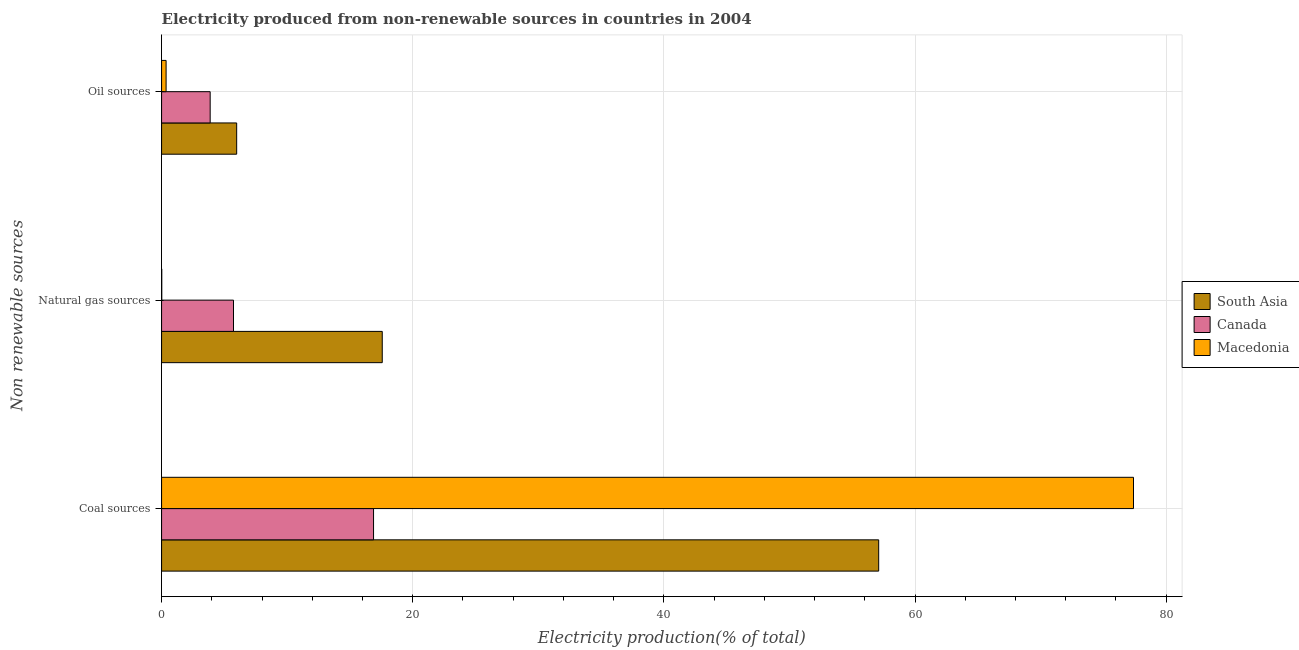How many groups of bars are there?
Offer a terse response. 3. Are the number of bars on each tick of the Y-axis equal?
Keep it short and to the point. Yes. What is the label of the 2nd group of bars from the top?
Offer a terse response. Natural gas sources. What is the percentage of electricity produced by oil sources in Canada?
Your answer should be very brief. 3.87. Across all countries, what is the maximum percentage of electricity produced by natural gas?
Your answer should be very brief. 17.57. Across all countries, what is the minimum percentage of electricity produced by natural gas?
Make the answer very short. 0.01. In which country was the percentage of electricity produced by coal maximum?
Offer a very short reply. Macedonia. In which country was the percentage of electricity produced by oil sources minimum?
Make the answer very short. Macedonia. What is the total percentage of electricity produced by oil sources in the graph?
Provide a short and direct response. 10.21. What is the difference between the percentage of electricity produced by natural gas in Canada and that in Macedonia?
Your answer should be very brief. 5.71. What is the difference between the percentage of electricity produced by coal in South Asia and the percentage of electricity produced by natural gas in Canada?
Provide a succinct answer. 51.38. What is the average percentage of electricity produced by oil sources per country?
Your answer should be very brief. 3.4. What is the difference between the percentage of electricity produced by oil sources and percentage of electricity produced by natural gas in South Asia?
Keep it short and to the point. -11.59. In how many countries, is the percentage of electricity produced by oil sources greater than 12 %?
Your answer should be very brief. 0. What is the ratio of the percentage of electricity produced by natural gas in Canada to that in Macedonia?
Offer a terse response. 381.86. What is the difference between the highest and the second highest percentage of electricity produced by oil sources?
Your answer should be compact. 2.11. What is the difference between the highest and the lowest percentage of electricity produced by oil sources?
Keep it short and to the point. 5.62. In how many countries, is the percentage of electricity produced by natural gas greater than the average percentage of electricity produced by natural gas taken over all countries?
Your answer should be compact. 1. Is the sum of the percentage of electricity produced by natural gas in Canada and South Asia greater than the maximum percentage of electricity produced by coal across all countries?
Your response must be concise. No. What does the 3rd bar from the top in Oil sources represents?
Provide a succinct answer. South Asia. How many bars are there?
Provide a short and direct response. 9. How many countries are there in the graph?
Offer a very short reply. 3. Where does the legend appear in the graph?
Provide a short and direct response. Center right. How many legend labels are there?
Provide a short and direct response. 3. What is the title of the graph?
Make the answer very short. Electricity produced from non-renewable sources in countries in 2004. Does "Georgia" appear as one of the legend labels in the graph?
Your answer should be very brief. No. What is the label or title of the X-axis?
Your answer should be very brief. Electricity production(% of total). What is the label or title of the Y-axis?
Keep it short and to the point. Non renewable sources. What is the Electricity production(% of total) of South Asia in Coal sources?
Your answer should be very brief. 57.11. What is the Electricity production(% of total) in Canada in Coal sources?
Ensure brevity in your answer.  16.88. What is the Electricity production(% of total) of Macedonia in Coal sources?
Offer a terse response. 77.4. What is the Electricity production(% of total) in South Asia in Natural gas sources?
Make the answer very short. 17.57. What is the Electricity production(% of total) of Canada in Natural gas sources?
Offer a terse response. 5.73. What is the Electricity production(% of total) in Macedonia in Natural gas sources?
Offer a very short reply. 0.01. What is the Electricity production(% of total) of South Asia in Oil sources?
Give a very brief answer. 5.98. What is the Electricity production(% of total) of Canada in Oil sources?
Make the answer very short. 3.87. What is the Electricity production(% of total) of Macedonia in Oil sources?
Provide a short and direct response. 0.36. Across all Non renewable sources, what is the maximum Electricity production(% of total) of South Asia?
Your answer should be compact. 57.11. Across all Non renewable sources, what is the maximum Electricity production(% of total) in Canada?
Provide a succinct answer. 16.88. Across all Non renewable sources, what is the maximum Electricity production(% of total) in Macedonia?
Offer a terse response. 77.4. Across all Non renewable sources, what is the minimum Electricity production(% of total) of South Asia?
Make the answer very short. 5.98. Across all Non renewable sources, what is the minimum Electricity production(% of total) in Canada?
Provide a succinct answer. 3.87. Across all Non renewable sources, what is the minimum Electricity production(% of total) in Macedonia?
Your answer should be compact. 0.01. What is the total Electricity production(% of total) of South Asia in the graph?
Ensure brevity in your answer.  80.66. What is the total Electricity production(% of total) of Canada in the graph?
Provide a short and direct response. 26.48. What is the total Electricity production(% of total) of Macedonia in the graph?
Ensure brevity in your answer.  77.77. What is the difference between the Electricity production(% of total) of South Asia in Coal sources and that in Natural gas sources?
Your response must be concise. 39.53. What is the difference between the Electricity production(% of total) in Canada in Coal sources and that in Natural gas sources?
Make the answer very short. 11.15. What is the difference between the Electricity production(% of total) of Macedonia in Coal sources and that in Natural gas sources?
Give a very brief answer. 77.38. What is the difference between the Electricity production(% of total) in South Asia in Coal sources and that in Oil sources?
Offer a terse response. 51.13. What is the difference between the Electricity production(% of total) of Canada in Coal sources and that in Oil sources?
Offer a terse response. 13.01. What is the difference between the Electricity production(% of total) in Macedonia in Coal sources and that in Oil sources?
Give a very brief answer. 77.04. What is the difference between the Electricity production(% of total) in South Asia in Natural gas sources and that in Oil sources?
Give a very brief answer. 11.59. What is the difference between the Electricity production(% of total) of Canada in Natural gas sources and that in Oil sources?
Your response must be concise. 1.86. What is the difference between the Electricity production(% of total) in Macedonia in Natural gas sources and that in Oil sources?
Ensure brevity in your answer.  -0.34. What is the difference between the Electricity production(% of total) of South Asia in Coal sources and the Electricity production(% of total) of Canada in Natural gas sources?
Ensure brevity in your answer.  51.38. What is the difference between the Electricity production(% of total) of South Asia in Coal sources and the Electricity production(% of total) of Macedonia in Natural gas sources?
Give a very brief answer. 57.09. What is the difference between the Electricity production(% of total) of Canada in Coal sources and the Electricity production(% of total) of Macedonia in Natural gas sources?
Give a very brief answer. 16.86. What is the difference between the Electricity production(% of total) in South Asia in Coal sources and the Electricity production(% of total) in Canada in Oil sources?
Your answer should be very brief. 53.24. What is the difference between the Electricity production(% of total) of South Asia in Coal sources and the Electricity production(% of total) of Macedonia in Oil sources?
Offer a very short reply. 56.75. What is the difference between the Electricity production(% of total) of Canada in Coal sources and the Electricity production(% of total) of Macedonia in Oil sources?
Give a very brief answer. 16.52. What is the difference between the Electricity production(% of total) in South Asia in Natural gas sources and the Electricity production(% of total) in Canada in Oil sources?
Offer a very short reply. 13.7. What is the difference between the Electricity production(% of total) in South Asia in Natural gas sources and the Electricity production(% of total) in Macedonia in Oil sources?
Your answer should be very brief. 17.21. What is the difference between the Electricity production(% of total) in Canada in Natural gas sources and the Electricity production(% of total) in Macedonia in Oil sources?
Offer a very short reply. 5.37. What is the average Electricity production(% of total) in South Asia per Non renewable sources?
Offer a terse response. 26.89. What is the average Electricity production(% of total) of Canada per Non renewable sources?
Offer a terse response. 8.83. What is the average Electricity production(% of total) in Macedonia per Non renewable sources?
Offer a terse response. 25.92. What is the difference between the Electricity production(% of total) of South Asia and Electricity production(% of total) of Canada in Coal sources?
Your response must be concise. 40.23. What is the difference between the Electricity production(% of total) in South Asia and Electricity production(% of total) in Macedonia in Coal sources?
Provide a short and direct response. -20.29. What is the difference between the Electricity production(% of total) of Canada and Electricity production(% of total) of Macedonia in Coal sources?
Your answer should be compact. -60.52. What is the difference between the Electricity production(% of total) in South Asia and Electricity production(% of total) in Canada in Natural gas sources?
Make the answer very short. 11.85. What is the difference between the Electricity production(% of total) in South Asia and Electricity production(% of total) in Macedonia in Natural gas sources?
Ensure brevity in your answer.  17.56. What is the difference between the Electricity production(% of total) of Canada and Electricity production(% of total) of Macedonia in Natural gas sources?
Provide a succinct answer. 5.71. What is the difference between the Electricity production(% of total) in South Asia and Electricity production(% of total) in Canada in Oil sources?
Your answer should be very brief. 2.11. What is the difference between the Electricity production(% of total) in South Asia and Electricity production(% of total) in Macedonia in Oil sources?
Provide a succinct answer. 5.62. What is the difference between the Electricity production(% of total) of Canada and Electricity production(% of total) of Macedonia in Oil sources?
Your response must be concise. 3.51. What is the ratio of the Electricity production(% of total) of South Asia in Coal sources to that in Natural gas sources?
Ensure brevity in your answer.  3.25. What is the ratio of the Electricity production(% of total) of Canada in Coal sources to that in Natural gas sources?
Give a very brief answer. 2.95. What is the ratio of the Electricity production(% of total) of Macedonia in Coal sources to that in Natural gas sources?
Make the answer very short. 5160. What is the ratio of the Electricity production(% of total) of South Asia in Coal sources to that in Oil sources?
Provide a succinct answer. 9.55. What is the ratio of the Electricity production(% of total) of Canada in Coal sources to that in Oil sources?
Your answer should be very brief. 4.36. What is the ratio of the Electricity production(% of total) of Macedonia in Coal sources to that in Oil sources?
Offer a very short reply. 215. What is the ratio of the Electricity production(% of total) of South Asia in Natural gas sources to that in Oil sources?
Offer a terse response. 2.94. What is the ratio of the Electricity production(% of total) in Canada in Natural gas sources to that in Oil sources?
Keep it short and to the point. 1.48. What is the ratio of the Electricity production(% of total) of Macedonia in Natural gas sources to that in Oil sources?
Give a very brief answer. 0.04. What is the difference between the highest and the second highest Electricity production(% of total) of South Asia?
Keep it short and to the point. 39.53. What is the difference between the highest and the second highest Electricity production(% of total) of Canada?
Your response must be concise. 11.15. What is the difference between the highest and the second highest Electricity production(% of total) in Macedonia?
Offer a very short reply. 77.04. What is the difference between the highest and the lowest Electricity production(% of total) in South Asia?
Offer a very short reply. 51.13. What is the difference between the highest and the lowest Electricity production(% of total) of Canada?
Provide a succinct answer. 13.01. What is the difference between the highest and the lowest Electricity production(% of total) of Macedonia?
Your answer should be very brief. 77.38. 